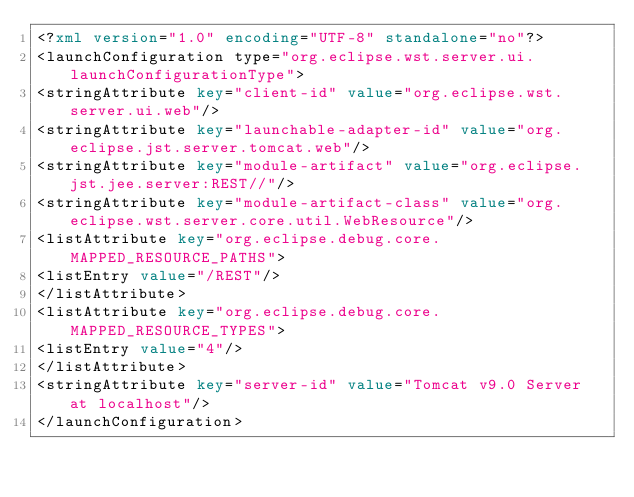<code> <loc_0><loc_0><loc_500><loc_500><_XML_><?xml version="1.0" encoding="UTF-8" standalone="no"?>
<launchConfiguration type="org.eclipse.wst.server.ui.launchConfigurationType">
<stringAttribute key="client-id" value="org.eclipse.wst.server.ui.web"/>
<stringAttribute key="launchable-adapter-id" value="org.eclipse.jst.server.tomcat.web"/>
<stringAttribute key="module-artifact" value="org.eclipse.jst.jee.server:REST//"/>
<stringAttribute key="module-artifact-class" value="org.eclipse.wst.server.core.util.WebResource"/>
<listAttribute key="org.eclipse.debug.core.MAPPED_RESOURCE_PATHS">
<listEntry value="/REST"/>
</listAttribute>
<listAttribute key="org.eclipse.debug.core.MAPPED_RESOURCE_TYPES">
<listEntry value="4"/>
</listAttribute>
<stringAttribute key="server-id" value="Tomcat v9.0 Server at localhost"/>
</launchConfiguration>
</code> 